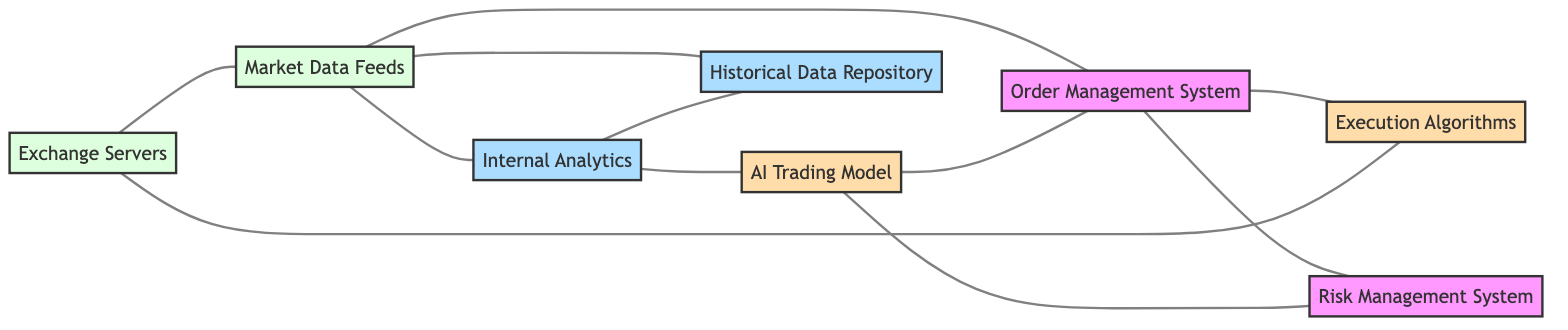What are the total number of nodes in the diagram? The diagram shows eight distinct entities labeled as nodes. These are: Exchange Servers, Market Data Feeds, Internal Analytics, Order Management System, AI Trading Model, Risk Management System, Execution Algorithms, and Historical Data Repository. Counting these gives a total of eight nodes.
Answer: 8 Which node is connected to both the Market Data Feeds and the Risk Management System? By examining the edges, we see that the internal Analytics node connects to the Market Data Feeds and has an edge to the Risk Management System as well. Therefore, the node that connects both is Internal Analytics.
Answer: Internal Analytics How many edges connect to the Order Management System? There are four distinct edges linked to the Order Management System: one from Market Data Feeds, one from AI Trading Model, one from Execution Algorithms, and one from Risk Management System. Hence, the total number of edges is four.
Answer: 4 Which two nodes do not directly connect to the Historical Data Repository? Looking at the connectivity, the nodes Execution Algorithms and AI Trading Model do not connect directly to the Historical Data Repository. Instead, edges lead from Market Data Feeds and Internal Analytics to the Historical Data Repository.
Answer: Execution Algorithms, AI Trading Model Is there a direct connection between the AI Trading Model and Exchange Servers? The diagram illustrates all connections, and there are no direct edges from the AI Trading Model to the Exchange Servers. The AI Trading Model only connects indirectly via Order Management System and Risk Management System.
Answer: No What is the relationship between the Execution Algorithms and Exchange Servers? The diagram shows an edge connecting Execution Algorithms to Exchange Servers, indicating a direct relationship. The Execution Algorithms send data back to the Exchange Servers after processing orders.
Answer: Direct connection 